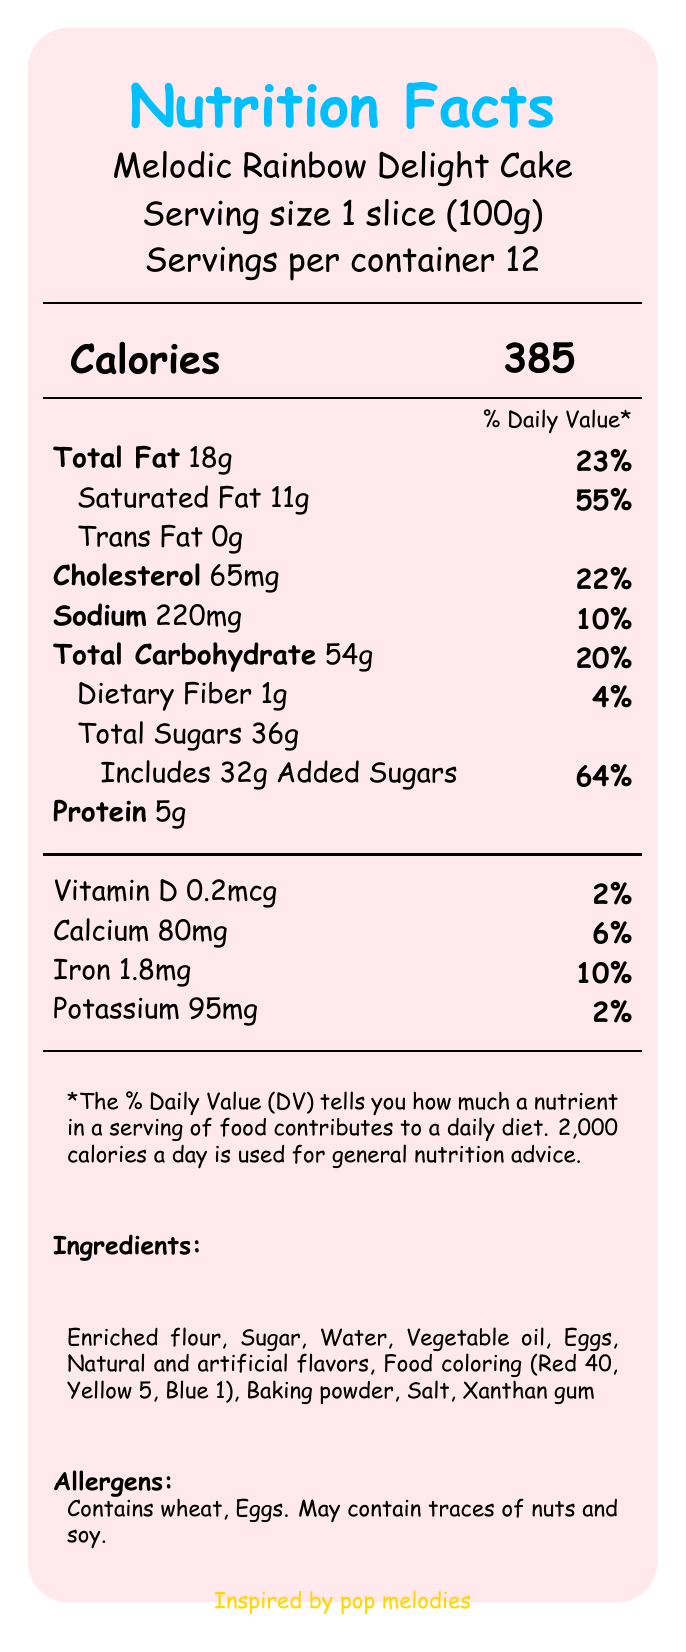What is the serving size for the Melodic Rainbow Delight Cake? The document specifies that the serving size for the cake is 1 slice, weighing 100g.
Answer: 1 slice (100g) How many servings are in one container of the Melodic Rainbow Delight Cake? The document indicates that there are 12 servings per container.
Answer: 12 How many calories are in one serving of the Melodic Rainbow Delight Cake? The document states that each serving contains 385 calories.
Answer: 385 What is the total fat content per serving? The document mentions that the total fat content per serving is 18g.
Answer: 18g What percentage of the daily value of saturated fat does one serving provide? The document shows that one serving provides 55% of the daily value for saturated fat.
Answer: 55% What is the amount of trans fat per serving? The document indicates that there are 0g of trans fat per serving.
Answer: 0g What is the total carbohydrate content per serving? The document states that the total carbohydrate content per serving is 54g.
Answer: 54g What are the total sugars in one serving of the cake? The document indicates that there are 36g of total sugars per serving.
Answer: 36g Which ingredient is not listed in the document? A) Enriched flour B) Water C) Almond milk D) Eggs The document lists "Enriched flour," "Water," and "Eggs" as ingredients but does not mention "Almond milk."
Answer: C) Almond milk What genre of music inspired the cake? A) Rock B) Jazz C) Pop D) Classical The document states that the cake was inspired by pop melodies.
Answer: C) Pop Is the Melodic Rainbow Delight Cake gluten-free? The document lists "Enriched flour" as an ingredient, which contains wheat, indicating that the cake is not gluten-free.
Answer: No Summarize the main nutritional content and artistic elements of the Melodic Rainbow Delight Cake. The cake has detailed nutritional information, highlighting its fat, carbohydrate, and protein content. It also emphasizes its visual appeal with multiple colorful layers and music-themed decorations.
Answer: The Melodic Rainbow Delight Cake is a colorful pop music-inspired dessert with 385 calories per slice, consisting of 18g fat, 54g carbohydrates, and 5g protein. It features six layers in various colors, a whipped cream cheese frosting, and edible music note decorations. From which bakery is the Melodic Rainbow Delight Cake manufactured? The document indicates that the manufacturer is "Harmony Bakes Artisan Bakery."
Answer: Harmony Bakes Artisan Bakery How many grams of dietary fiber are in one serving of the Melodic Rainbow Delight Cake? The document states that there is 1g of dietary fiber per serving.
Answer: 1g What are the frosting and decoration types mentioned for the cake? The document describes that the cake is decorated with whipped cream cheese frosting and edible music notes and treble clefs.
Answer: Whipped cream cheese frosting and edible music notes and treble clefs What colors are included in the cake's color palette? The document lists these six colors as part of the cake's color palette.
Answer: Strawberry red, Tangerine orange, Lemon yellow, Lime green, Blueberry blue, Grape purple Is there any information about the cost of the Melodic Rainbow Delight Cake? The document does not provide any details regarding the price or cost of the cake.
Answer: Not enough information 